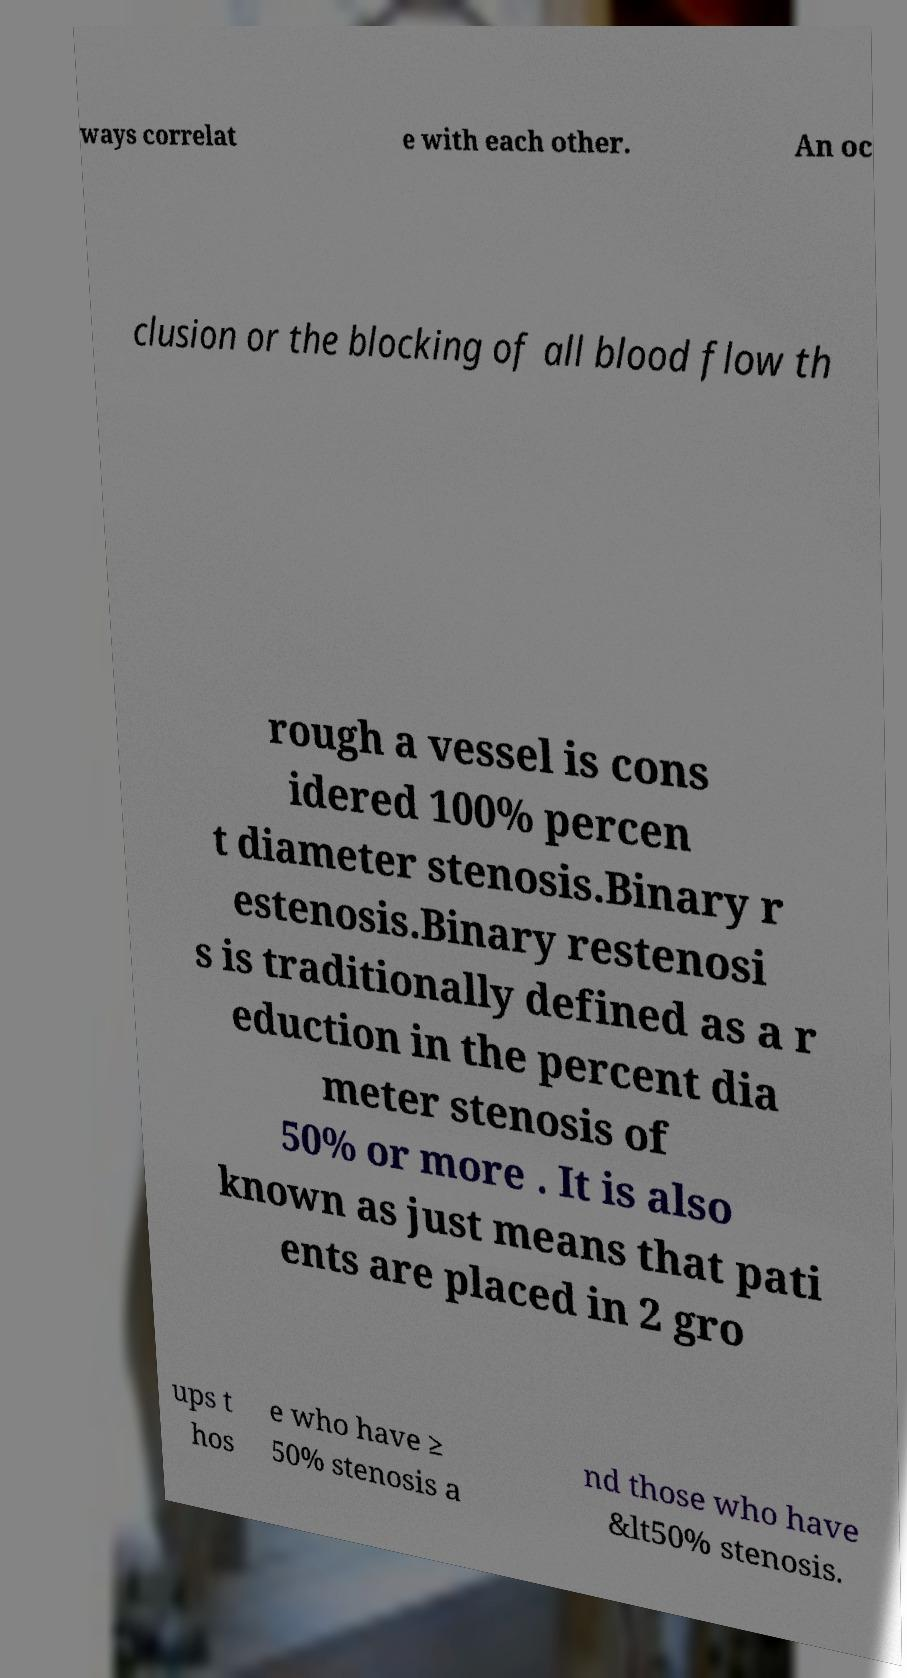What messages or text are displayed in this image? I need them in a readable, typed format. ways correlat e with each other. An oc clusion or the blocking of all blood flow th rough a vessel is cons idered 100% percen t diameter stenosis.Binary r estenosis.Binary restenosi s is traditionally defined as a r eduction in the percent dia meter stenosis of 50% or more . It is also known as just means that pati ents are placed in 2 gro ups t hos e who have ≥ 50% stenosis a nd those who have &lt50% stenosis. 